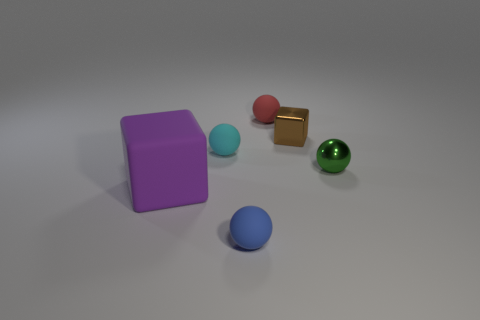Add 2 tiny cyan cubes. How many objects exist? 8 Subtract all tiny cyan spheres. How many spheres are left? 3 Subtract all purple blocks. How many blocks are left? 1 Subtract all cubes. How many objects are left? 4 Add 4 brown objects. How many brown objects exist? 5 Subtract 1 purple blocks. How many objects are left? 5 Subtract all yellow cubes. Subtract all red cylinders. How many cubes are left? 2 Subtract all yellow cubes. How many purple balls are left? 0 Subtract all red spheres. Subtract all tiny matte things. How many objects are left? 2 Add 2 tiny red spheres. How many tiny red spheres are left? 3 